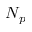Convert formula to latex. <formula><loc_0><loc_0><loc_500><loc_500>N _ { p }</formula> 